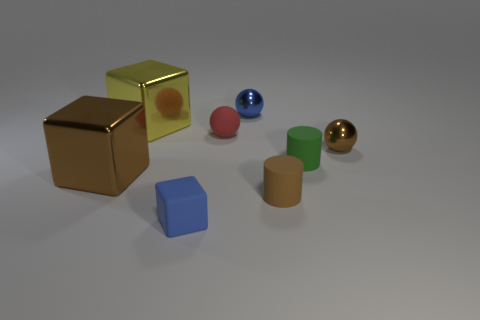What's the texture of the surface the objects are resting on? The objects appear to be resting on a smooth and even surface, likely a representation of a matte finished material. 